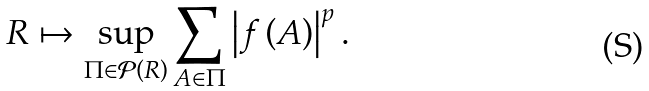Convert formula to latex. <formula><loc_0><loc_0><loc_500><loc_500>R \mapsto \sup _ { \Pi \in \mathcal { P } \left ( R \right ) } \sum _ { A \in \Pi } \left | f \left ( A \right ) \right | ^ { p } .</formula> 